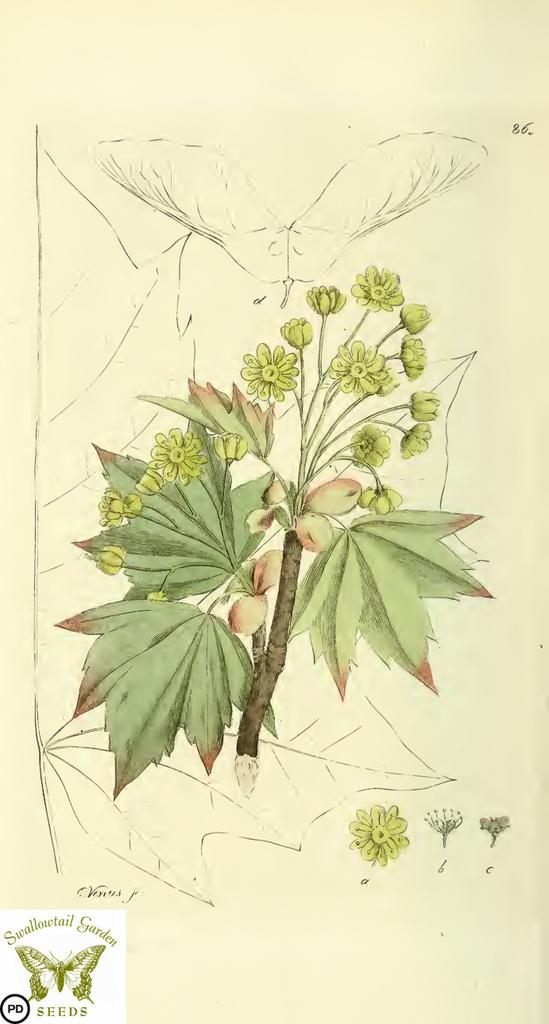What is the main subject of the image? The image contains a painting. What elements are depicted in the painting? The painting depicts leaves, flowers, and fruits. Where is the logo located in the image? The logo is at the left bottom of the image. What else is present at the left bottom of the image? There is text at the left bottom of the image. What type of fan is visible in the painting? There is no fan present in the painting; it depicts leaves, flowers, and fruits. Can you tell me how many boats are shown in the painting? There are no boats depicted in the painting; it focuses on leaves, flowers, and fruits. 